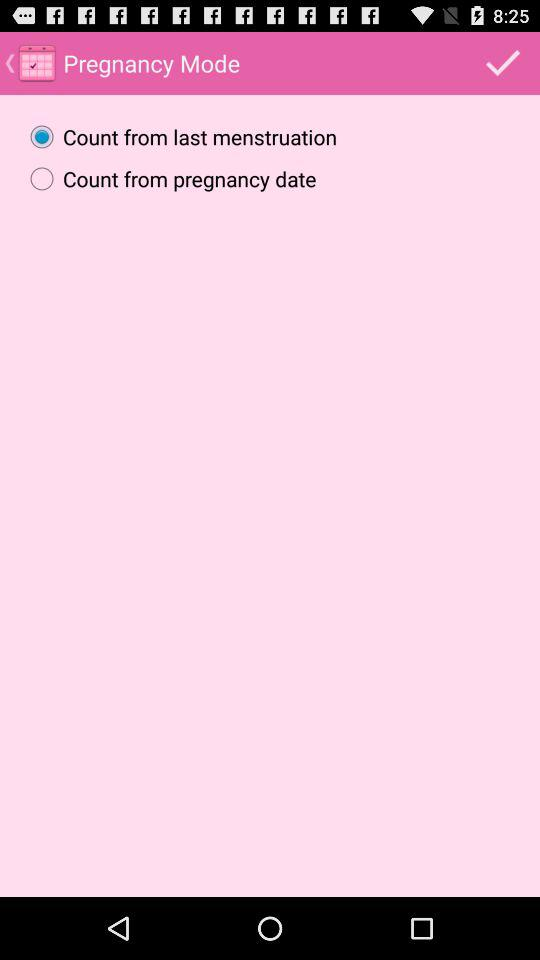When was the last menstruation date?
When the provided information is insufficient, respond with <no answer>. <no answer> 